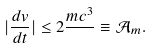Convert formula to latex. <formula><loc_0><loc_0><loc_500><loc_500>| \frac { d v } { d t } | \leq 2 \frac { m c ^ { 3 } } { } \equiv \mathcal { A } _ { m } .</formula> 